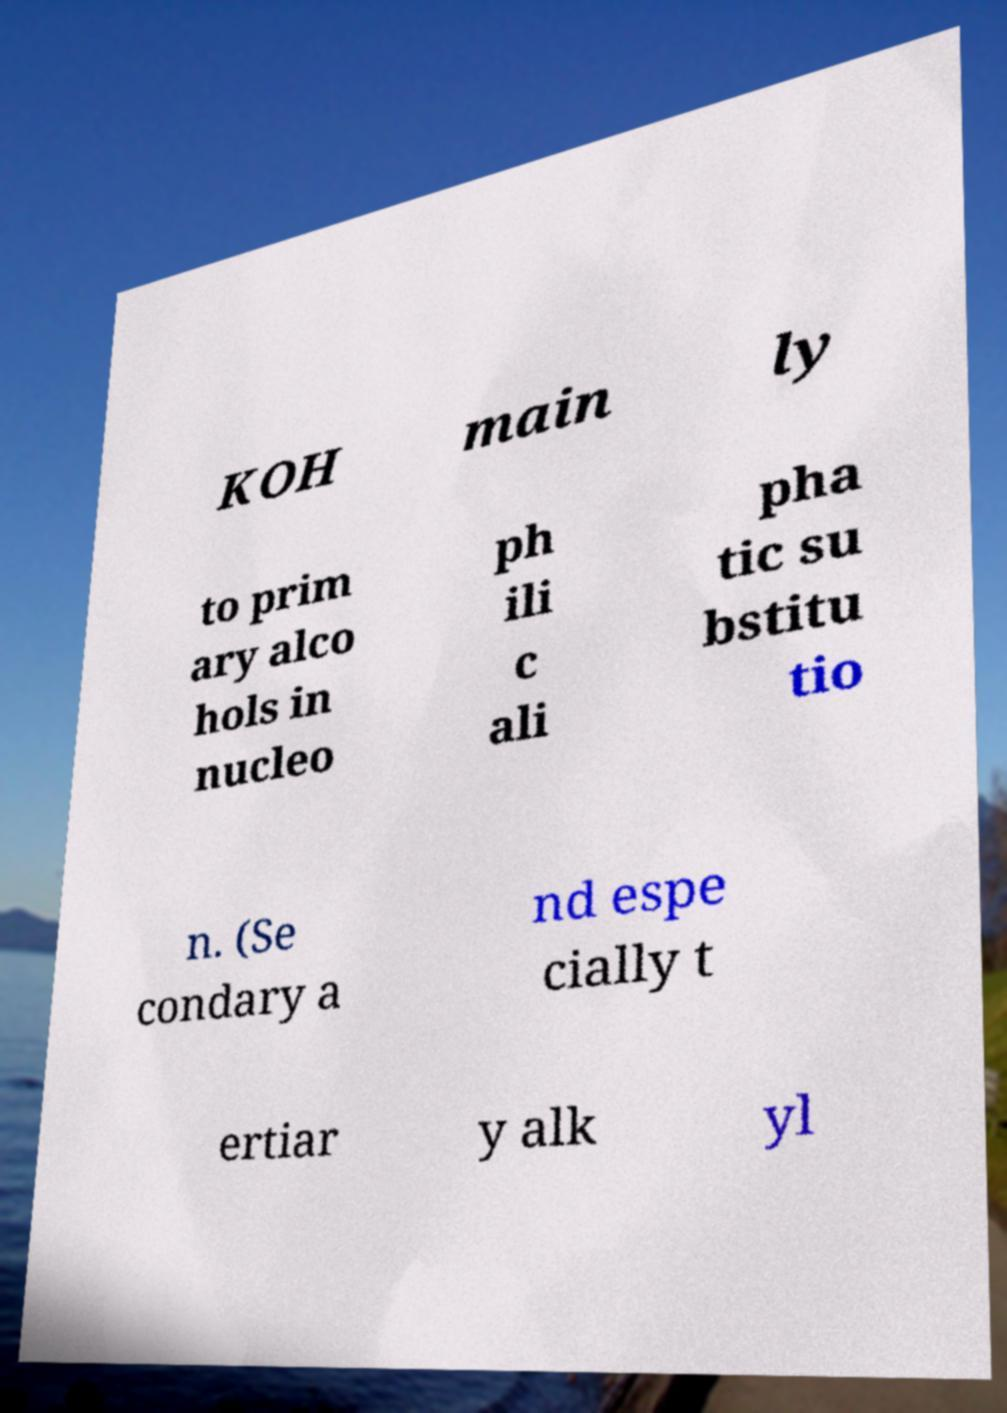Can you read and provide the text displayed in the image?This photo seems to have some interesting text. Can you extract and type it out for me? KOH main ly to prim ary alco hols in nucleo ph ili c ali pha tic su bstitu tio n. (Se condary a nd espe cially t ertiar y alk yl 